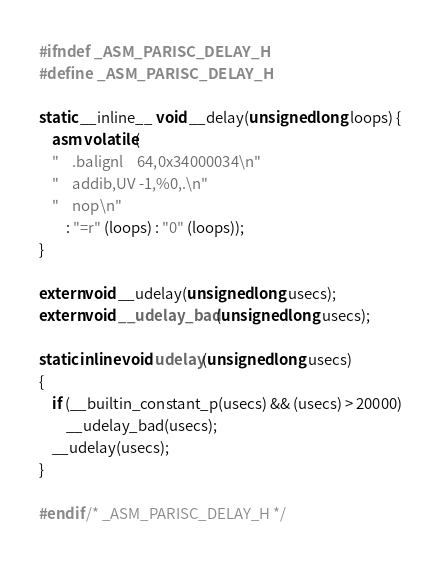Convert code to text. <code><loc_0><loc_0><loc_500><loc_500><_C_>#ifndef _ASM_PARISC_DELAY_H
#define _ASM_PARISC_DELAY_H

static __inline__ void __delay(unsigned long loops) {
	asm volatile(
	"	.balignl	64,0x34000034\n"
	"	addib,UV -1,%0,.\n"
	"	nop\n"
		: "=r" (loops) : "0" (loops));
}

extern void __udelay(unsigned long usecs);
extern void __udelay_bad(unsigned long usecs);

static inline void udelay(unsigned long usecs)
{
	if (__builtin_constant_p(usecs) && (usecs) > 20000)
		__udelay_bad(usecs);
	__udelay(usecs);
}

#endif /* _ASM_PARISC_DELAY_H */
</code> 